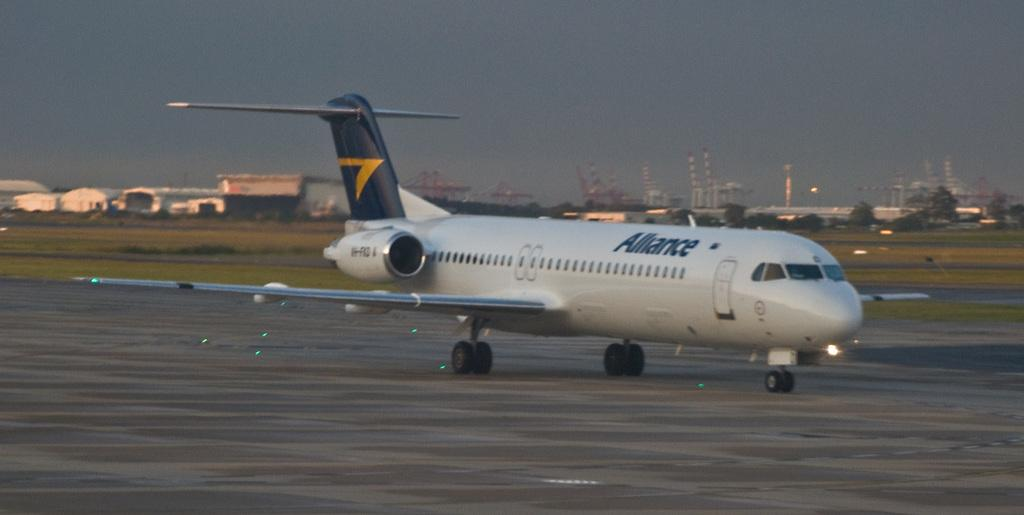<image>
Write a terse but informative summary of the picture. A white commercial jet that says Alliance is taxiing on a runway. 